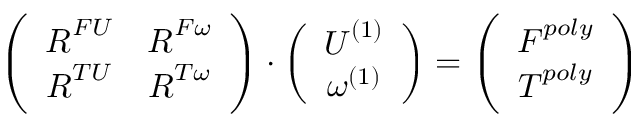Convert formula to latex. <formula><loc_0><loc_0><loc_500><loc_500>\left ( \begin{array} { c c } { R ^ { F U } } & { R ^ { F \omega } } \\ { R ^ { T U } } & { R ^ { T \omega } } \end{array} \right ) \cdot \left ( \begin{array} { c } { U ^ { ( 1 ) } } \\ { \omega ^ { ( 1 ) } } \end{array} \right ) = \left ( \begin{array} { c } { F ^ { p o l y } } \\ { T ^ { p o l y } } \end{array} \right )</formula> 